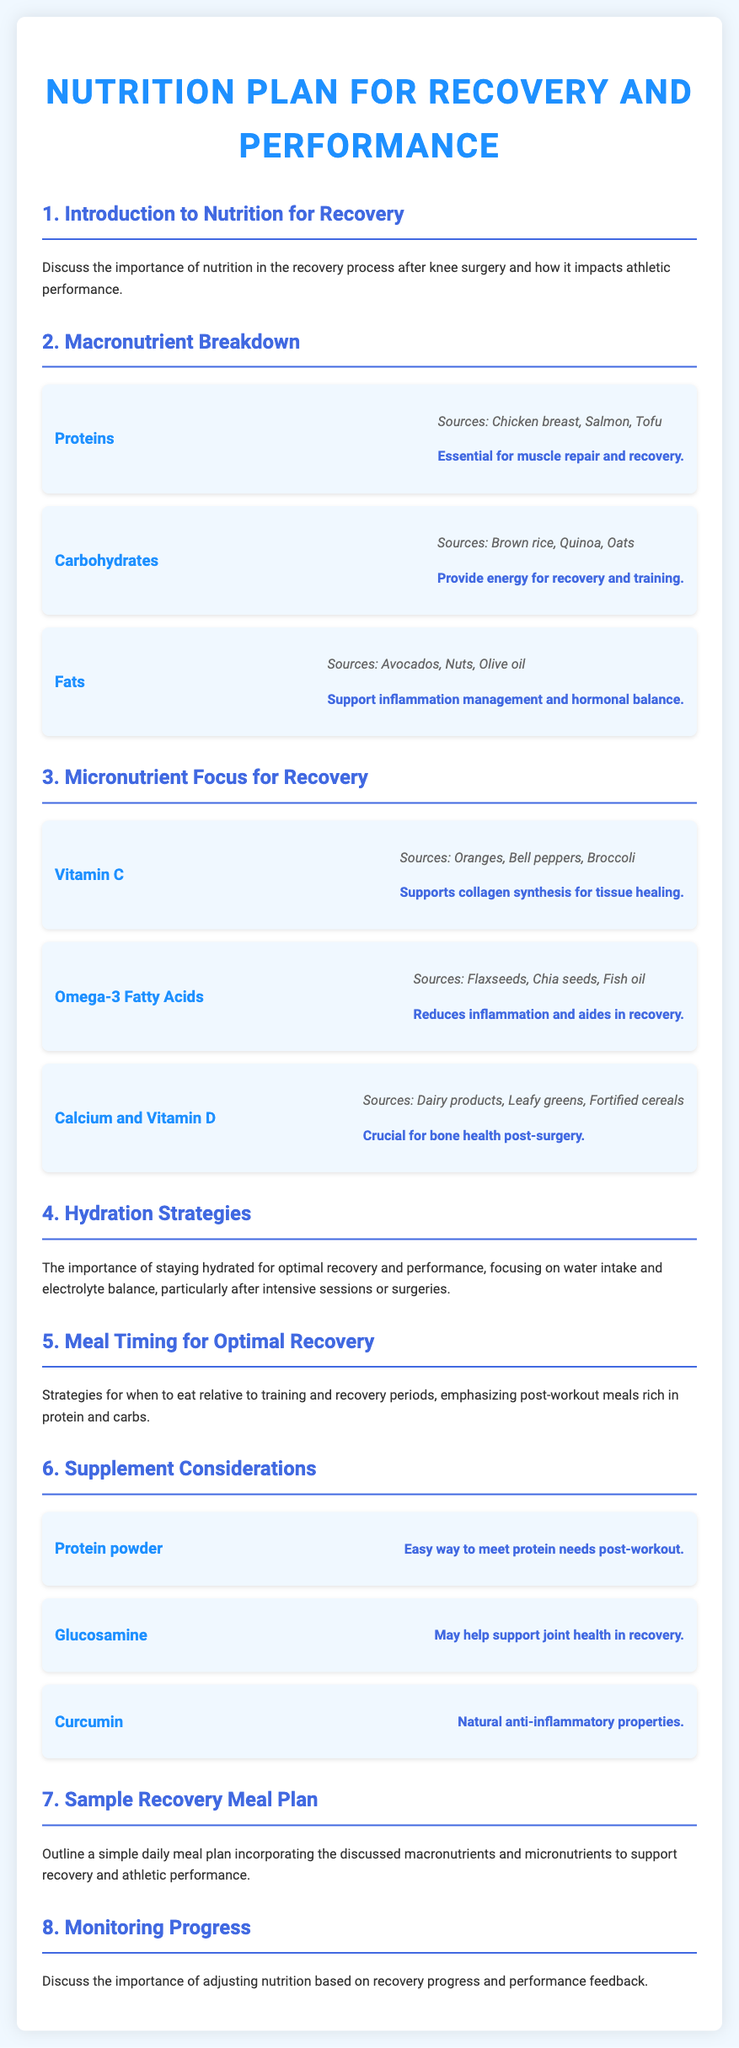what is the title of the document? The title is prominently displayed at the top of the document, indicating its focus on nutrition.
Answer: Nutrition Plan for Recovery and Performance what is the function of proteins in recovery? The document specifies the role of proteins in relation to recovery, emphasizing their importance in healing.
Answer: Essential for muscle repair and recovery which vitamin is crucial for collagen synthesis? The document notes the importance of specific micronutrients for recovery, particularly for tissue healing.
Answer: Vitamin C what are two good sources of Omega-3 fatty acids? The document lists sources of Omega-3 fatty acids under the micronutrient focus section.
Answer: Flaxseeds, Chia seeds how many sections are there in the document? The document includes a structured format with clearly defined sections, allowing for easy navigation.
Answer: Eight what is indicated as a hydration strategy? The document discusses the significance of hydration and its impact on recovery and performance.
Answer: Importance of staying hydrated what type of supplement may support joint health? The document mentions specific supplements that may aid in recovery and their functions.
Answer: Glucosamine what is the recommended post-workout meal composition? The document outlines strategies related to meal timing, specifically after workout periods.
Answer: Rich in protein and carbs 